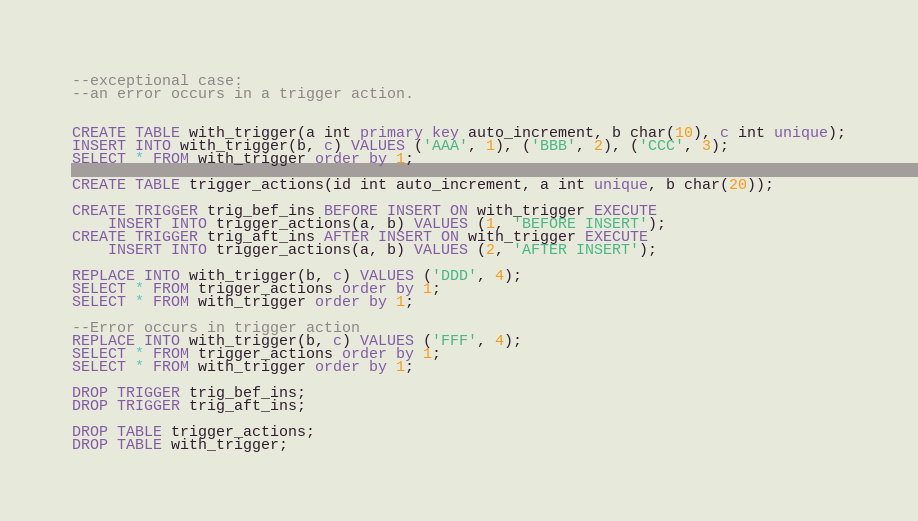<code> <loc_0><loc_0><loc_500><loc_500><_SQL_>--exceptional case:
--an error occurs in a trigger action.


CREATE TABLE with_trigger(a int primary key auto_increment, b char(10), c int unique);
INSERT INTO with_trigger(b, c) VALUES ('AAA', 1), ('BBB', 2), ('CCC', 3);
SELECT * FROM with_trigger order by 1;

CREATE TABLE trigger_actions(id int auto_increment, a int unique, b char(20));

CREATE TRIGGER trig_bef_ins BEFORE INSERT ON with_trigger EXECUTE
	INSERT INTO trigger_actions(a, b) VALUES (1, 'BEFORE INSERT');
CREATE TRIGGER trig_aft_ins AFTER INSERT ON with_trigger EXECUTE
	INSERT INTO trigger_actions(a, b) VALUES (2, 'AFTER INSERT');

REPLACE INTO with_trigger(b, c) VALUES ('DDD', 4);
SELECT * FROM trigger_actions order by 1;
SELECT * FROM with_trigger order by 1;

--Error occurs in trigger action
REPLACE INTO with_trigger(b, c) VALUES ('FFF', 4);
SELECT * FROM trigger_actions order by 1;
SELECT * FROM with_trigger order by 1;

DROP TRIGGER trig_bef_ins;
DROP TRIGGER trig_aft_ins;

DROP TABLE trigger_actions;
DROP TABLE with_trigger;
</code> 